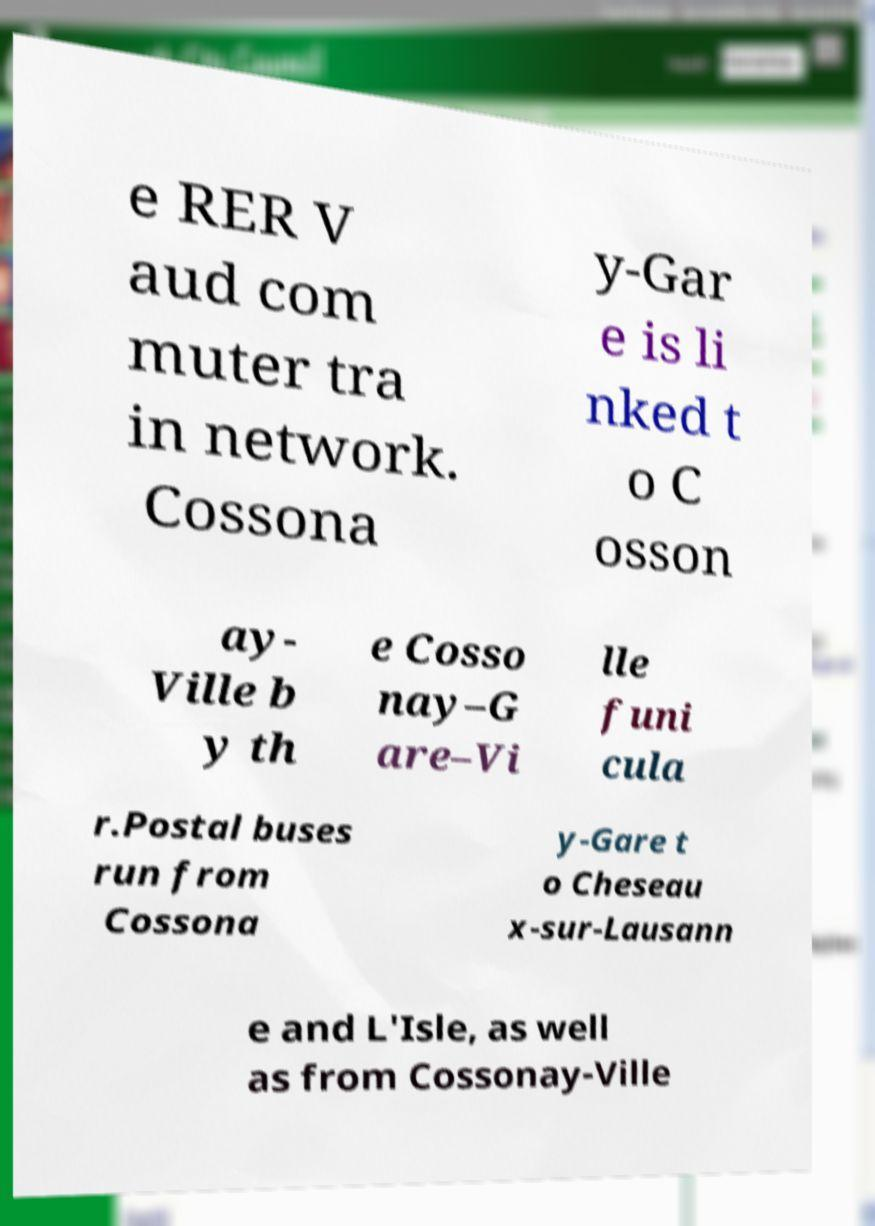Can you accurately transcribe the text from the provided image for me? e RER V aud com muter tra in network. Cossona y-Gar e is li nked t o C osson ay- Ville b y th e Cosso nay–G are–Vi lle funi cula r.Postal buses run from Cossona y-Gare t o Cheseau x-sur-Lausann e and L'Isle, as well as from Cossonay-Ville 